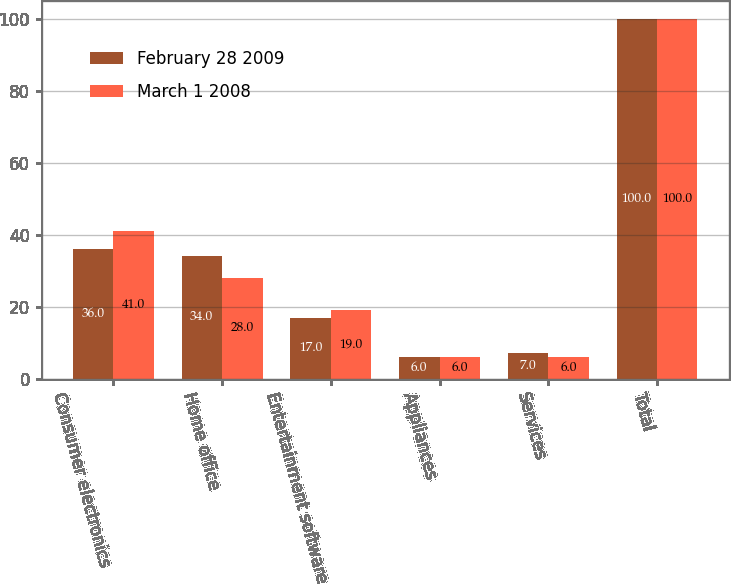Convert chart to OTSL. <chart><loc_0><loc_0><loc_500><loc_500><stacked_bar_chart><ecel><fcel>Consumer electronics<fcel>Home office<fcel>Entertainment software<fcel>Appliances<fcel>Services<fcel>Total<nl><fcel>February 28 2009<fcel>36<fcel>34<fcel>17<fcel>6<fcel>7<fcel>100<nl><fcel>March 1 2008<fcel>41<fcel>28<fcel>19<fcel>6<fcel>6<fcel>100<nl></chart> 